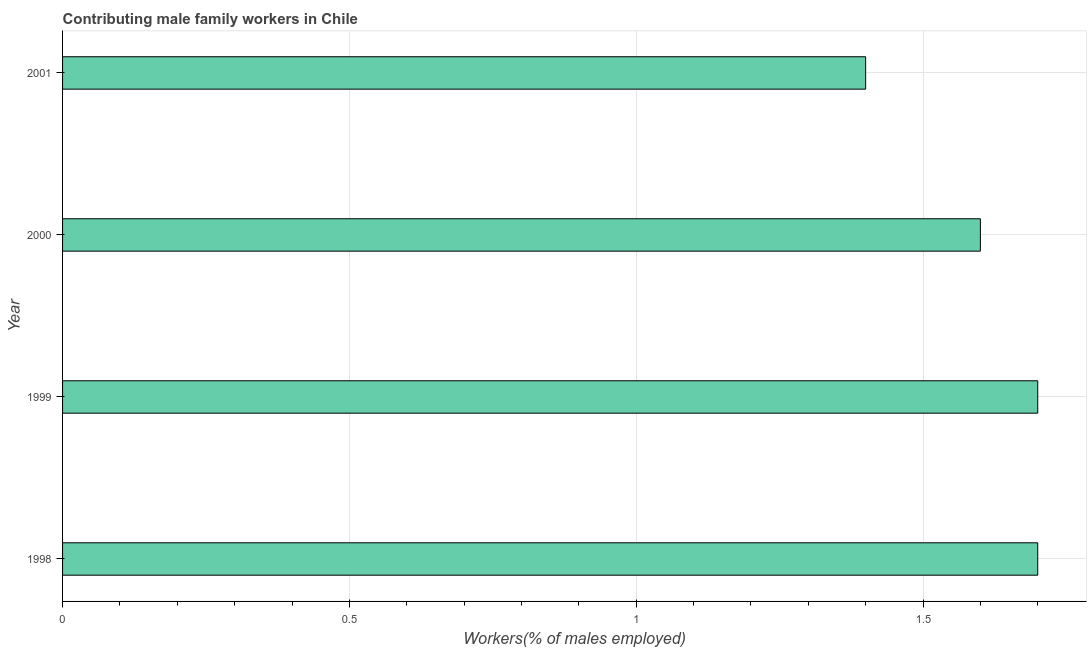What is the title of the graph?
Offer a terse response. Contributing male family workers in Chile. What is the label or title of the X-axis?
Your answer should be very brief. Workers(% of males employed). What is the label or title of the Y-axis?
Your answer should be very brief. Year. What is the contributing male family workers in 1998?
Your answer should be very brief. 1.7. Across all years, what is the maximum contributing male family workers?
Your answer should be very brief. 1.7. Across all years, what is the minimum contributing male family workers?
Keep it short and to the point. 1.4. What is the sum of the contributing male family workers?
Your answer should be very brief. 6.4. What is the median contributing male family workers?
Provide a succinct answer. 1.65. In how many years, is the contributing male family workers greater than 0.1 %?
Ensure brevity in your answer.  4. Do a majority of the years between 1999 and 2000 (inclusive) have contributing male family workers greater than 0.6 %?
Your answer should be compact. Yes. What is the ratio of the contributing male family workers in 1998 to that in 1999?
Give a very brief answer. 1. Is the contributing male family workers in 1998 less than that in 2000?
Your response must be concise. No. Is the difference between the contributing male family workers in 2000 and 2001 greater than the difference between any two years?
Offer a terse response. No. What is the difference between the highest and the second highest contributing male family workers?
Keep it short and to the point. 0. Is the sum of the contributing male family workers in 1998 and 2000 greater than the maximum contributing male family workers across all years?
Your answer should be very brief. Yes. What is the difference between the highest and the lowest contributing male family workers?
Provide a succinct answer. 0.3. What is the difference between two consecutive major ticks on the X-axis?
Offer a very short reply. 0.5. What is the Workers(% of males employed) of 1998?
Make the answer very short. 1.7. What is the Workers(% of males employed) in 1999?
Provide a succinct answer. 1.7. What is the Workers(% of males employed) in 2000?
Make the answer very short. 1.6. What is the Workers(% of males employed) of 2001?
Your answer should be very brief. 1.4. What is the difference between the Workers(% of males employed) in 1998 and 1999?
Your answer should be compact. 0. What is the difference between the Workers(% of males employed) in 1999 and 2001?
Provide a succinct answer. 0.3. What is the difference between the Workers(% of males employed) in 2000 and 2001?
Ensure brevity in your answer.  0.2. What is the ratio of the Workers(% of males employed) in 1998 to that in 2000?
Ensure brevity in your answer.  1.06. What is the ratio of the Workers(% of males employed) in 1998 to that in 2001?
Your answer should be very brief. 1.21. What is the ratio of the Workers(% of males employed) in 1999 to that in 2000?
Your response must be concise. 1.06. What is the ratio of the Workers(% of males employed) in 1999 to that in 2001?
Your response must be concise. 1.21. What is the ratio of the Workers(% of males employed) in 2000 to that in 2001?
Your answer should be compact. 1.14. 